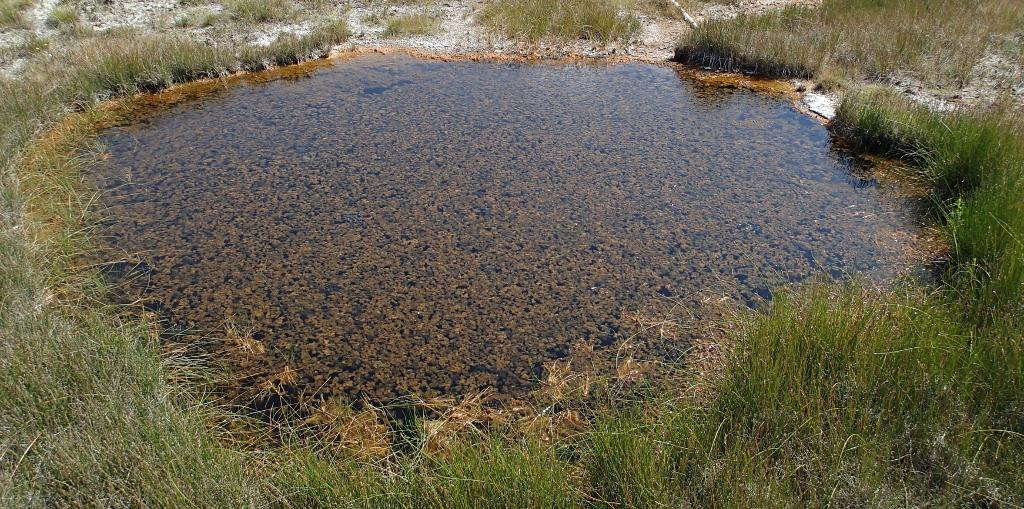What can be seen in the image that is fluid and transparent? There is water visible in the image. What type of vegetation is present in the image? There is green-colored grass in the image. What type of oil can be seen flowing in the image? There is no oil present in the image; it only features water and green-colored grass. What type of vacation destination is depicted in the image? The image does not depict a vacation destination; it only features water and green-colored grass. 